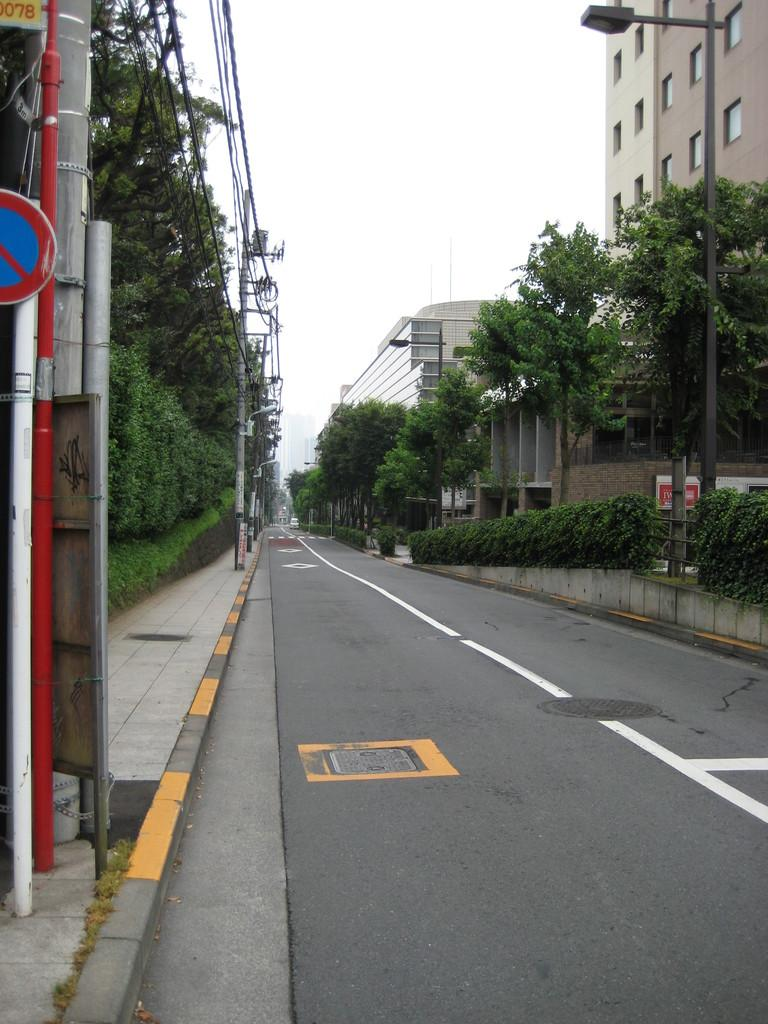What is located in the center of the image? There are trees, a road, poles, wires, and sign boards in the center of the image. What can be seen in the background of the image? There are buildings, sky, clouds, a wall, windows, and trees visible in the background of the image. Can you tell me how many baseballs are lying on the road in the image? There are no baseballs present in the image; it features trees, a road, poles, wires, and sign boards in the center. What type of drain is visible in the image? There is no drain present in the image. 